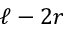<formula> <loc_0><loc_0><loc_500><loc_500>\ell - 2 r</formula> 